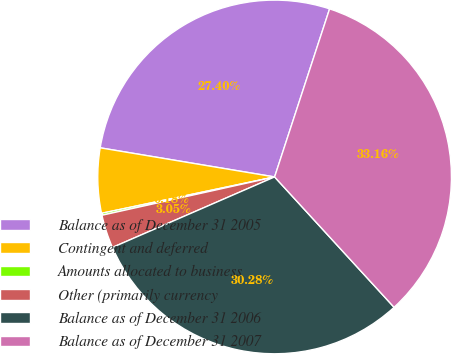Convert chart to OTSL. <chart><loc_0><loc_0><loc_500><loc_500><pie_chart><fcel>Balance as of December 31 2005<fcel>Contingent and deferred<fcel>Amounts allocated to business<fcel>Other (primarily currency<fcel>Balance as of December 31 2006<fcel>Balance as of December 31 2007<nl><fcel>27.4%<fcel>5.93%<fcel>0.18%<fcel>3.05%<fcel>30.28%<fcel>33.16%<nl></chart> 